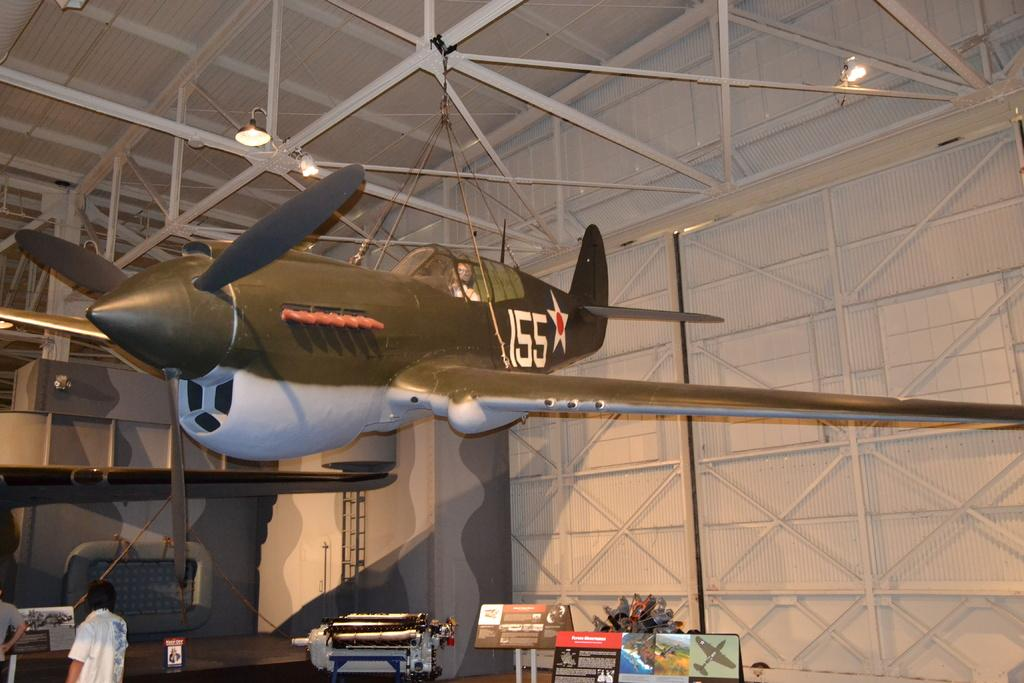<image>
Describe the image concisely. A small airplane in a hangar with 155 on its tail. 